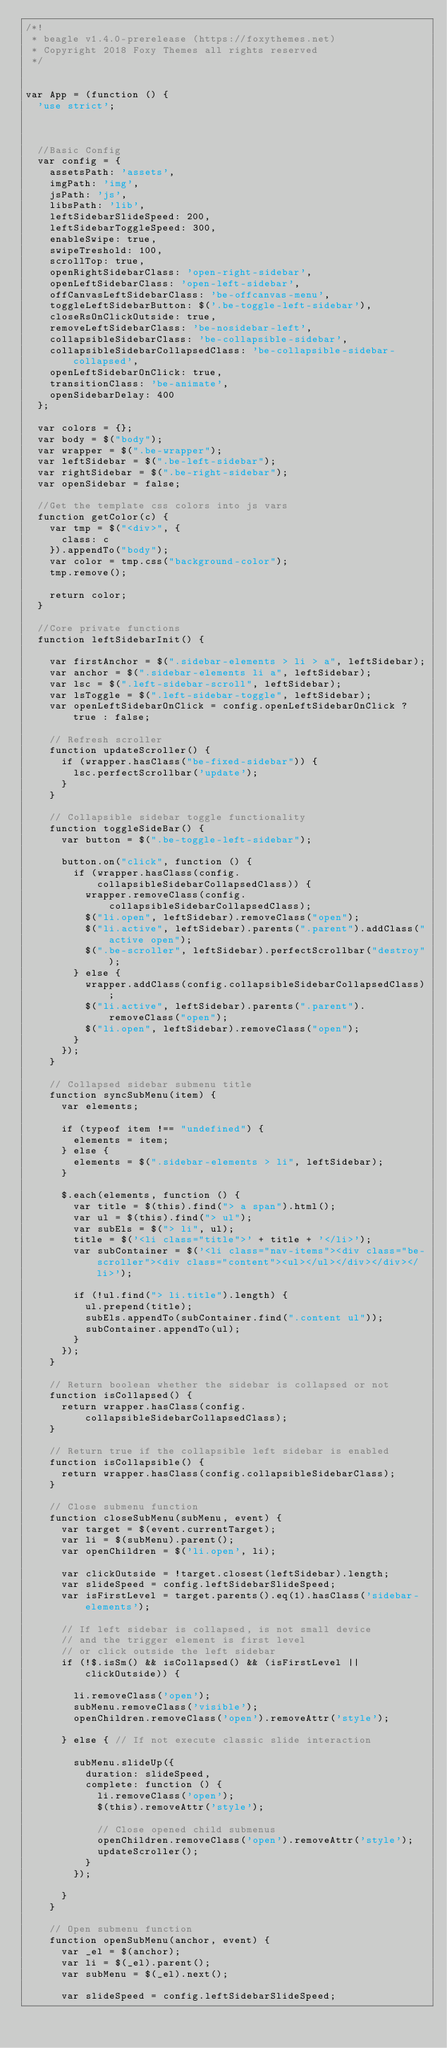Convert code to text. <code><loc_0><loc_0><loc_500><loc_500><_JavaScript_>/*!
 * beagle v1.4.0-prerelease (https://foxythemes.net)
 * Copyright 2018 Foxy Themes all rights reserved 
 */


var App = (function () {
  'use strict';



  //Basic Config
  var config = {
    assetsPath: 'assets',
    imgPath: 'img',
    jsPath: 'js',
    libsPath: 'lib',
    leftSidebarSlideSpeed: 200,
    leftSidebarToggleSpeed: 300,
    enableSwipe: true,
    swipeTreshold: 100,
    scrollTop: true,
    openRightSidebarClass: 'open-right-sidebar',
    openLeftSidebarClass: 'open-left-sidebar',
    offCanvasLeftSidebarClass: 'be-offcanvas-menu',
    toggleLeftSidebarButton: $('.be-toggle-left-sidebar'),
    closeRsOnClickOutside: true,
    removeLeftSidebarClass: 'be-nosidebar-left',
    collapsibleSidebarClass: 'be-collapsible-sidebar',
    collapsibleSidebarCollapsedClass: 'be-collapsible-sidebar-collapsed',
    openLeftSidebarOnClick: true,
    transitionClass: 'be-animate',
    openSidebarDelay: 400
  };

  var colors = {};
  var body = $("body");
  var wrapper = $(".be-wrapper");
  var leftSidebar = $(".be-left-sidebar");
  var rightSidebar = $(".be-right-sidebar");
  var openSidebar = false;

  //Get the template css colors into js vars
  function getColor(c) {
    var tmp = $("<div>", {
      class: c
    }).appendTo("body");
    var color = tmp.css("background-color");
    tmp.remove();

    return color;
  }

  //Core private functions
  function leftSidebarInit() {

    var firstAnchor = $(".sidebar-elements > li > a", leftSidebar);
    var anchor = $(".sidebar-elements li a", leftSidebar);
    var lsc = $(".left-sidebar-scroll", leftSidebar);
    var lsToggle = $(".left-sidebar-toggle", leftSidebar);
    var openLeftSidebarOnClick = config.openLeftSidebarOnClick ? true : false;

    // Refresh scroller
    function updateScroller() {
      if (wrapper.hasClass("be-fixed-sidebar")) {
        lsc.perfectScrollbar('update');
      }
    }

    // Collapsible sidebar toggle functionality
    function toggleSideBar() {
      var button = $(".be-toggle-left-sidebar");

      button.on("click", function () {
        if (wrapper.hasClass(config.collapsibleSidebarCollapsedClass)) {
          wrapper.removeClass(config.collapsibleSidebarCollapsedClass);
          $("li.open", leftSidebar).removeClass("open");
          $("li.active", leftSidebar).parents(".parent").addClass("active open");
          $(".be-scroller", leftSidebar).perfectScrollbar("destroy");
        } else {
          wrapper.addClass(config.collapsibleSidebarCollapsedClass);
          $("li.active", leftSidebar).parents(".parent").removeClass("open");
          $("li.open", leftSidebar).removeClass("open");
        }
      });
    }

    // Collapsed sidebar submenu title
    function syncSubMenu(item) {
      var elements;

      if (typeof item !== "undefined") {
        elements = item;
      } else {
        elements = $(".sidebar-elements > li", leftSidebar);
      }

      $.each(elements, function () {
        var title = $(this).find("> a span").html();
        var ul = $(this).find("> ul");
        var subEls = $("> li", ul);
        title = $('<li class="title">' + title + '</li>');
        var subContainer = $('<li class="nav-items"><div class="be-scroller"><div class="content"><ul></ul></div></div></li>');

        if (!ul.find("> li.title").length) {
          ul.prepend(title);
          subEls.appendTo(subContainer.find(".content ul"));
          subContainer.appendTo(ul);
        }
      });
    }

    // Return boolean whether the sidebar is collapsed or not
    function isCollapsed() {
      return wrapper.hasClass(config.collapsibleSidebarCollapsedClass);
    }

    // Return true if the collapsible left sidebar is enabled 
    function isCollapsible() {
      return wrapper.hasClass(config.collapsibleSidebarClass);
    }

    // Close submenu function
    function closeSubMenu(subMenu, event) {
      var target = $(event.currentTarget);
      var li = $(subMenu).parent();
      var openChildren = $('li.open', li);

      var clickOutside = !target.closest(leftSidebar).length;
      var slideSpeed = config.leftSidebarSlideSpeed;
      var isFirstLevel = target.parents().eq(1).hasClass('sidebar-elements');

      // If left sidebar is collapsed, is not small device 
      // and the trigger element is first level 
      // or click outside the left sidebar
      if (!$.isSm() && isCollapsed() && (isFirstLevel || clickOutside)) {

        li.removeClass('open');
        subMenu.removeClass('visible');
        openChildren.removeClass('open').removeAttr('style');

      } else { // If not execute classic slide interaction

        subMenu.slideUp({
          duration: slideSpeed,
          complete: function () {
            li.removeClass('open');
            $(this).removeAttr('style');

            // Close opened child submenus
            openChildren.removeClass('open').removeAttr('style');
            updateScroller();
          }
        });

      }
    }

    // Open submenu function
    function openSubMenu(anchor, event) {
      var _el = $(anchor);
      var li = $(_el).parent();
      var subMenu = $(_el).next();

      var slideSpeed = config.leftSidebarSlideSpeed;</code> 